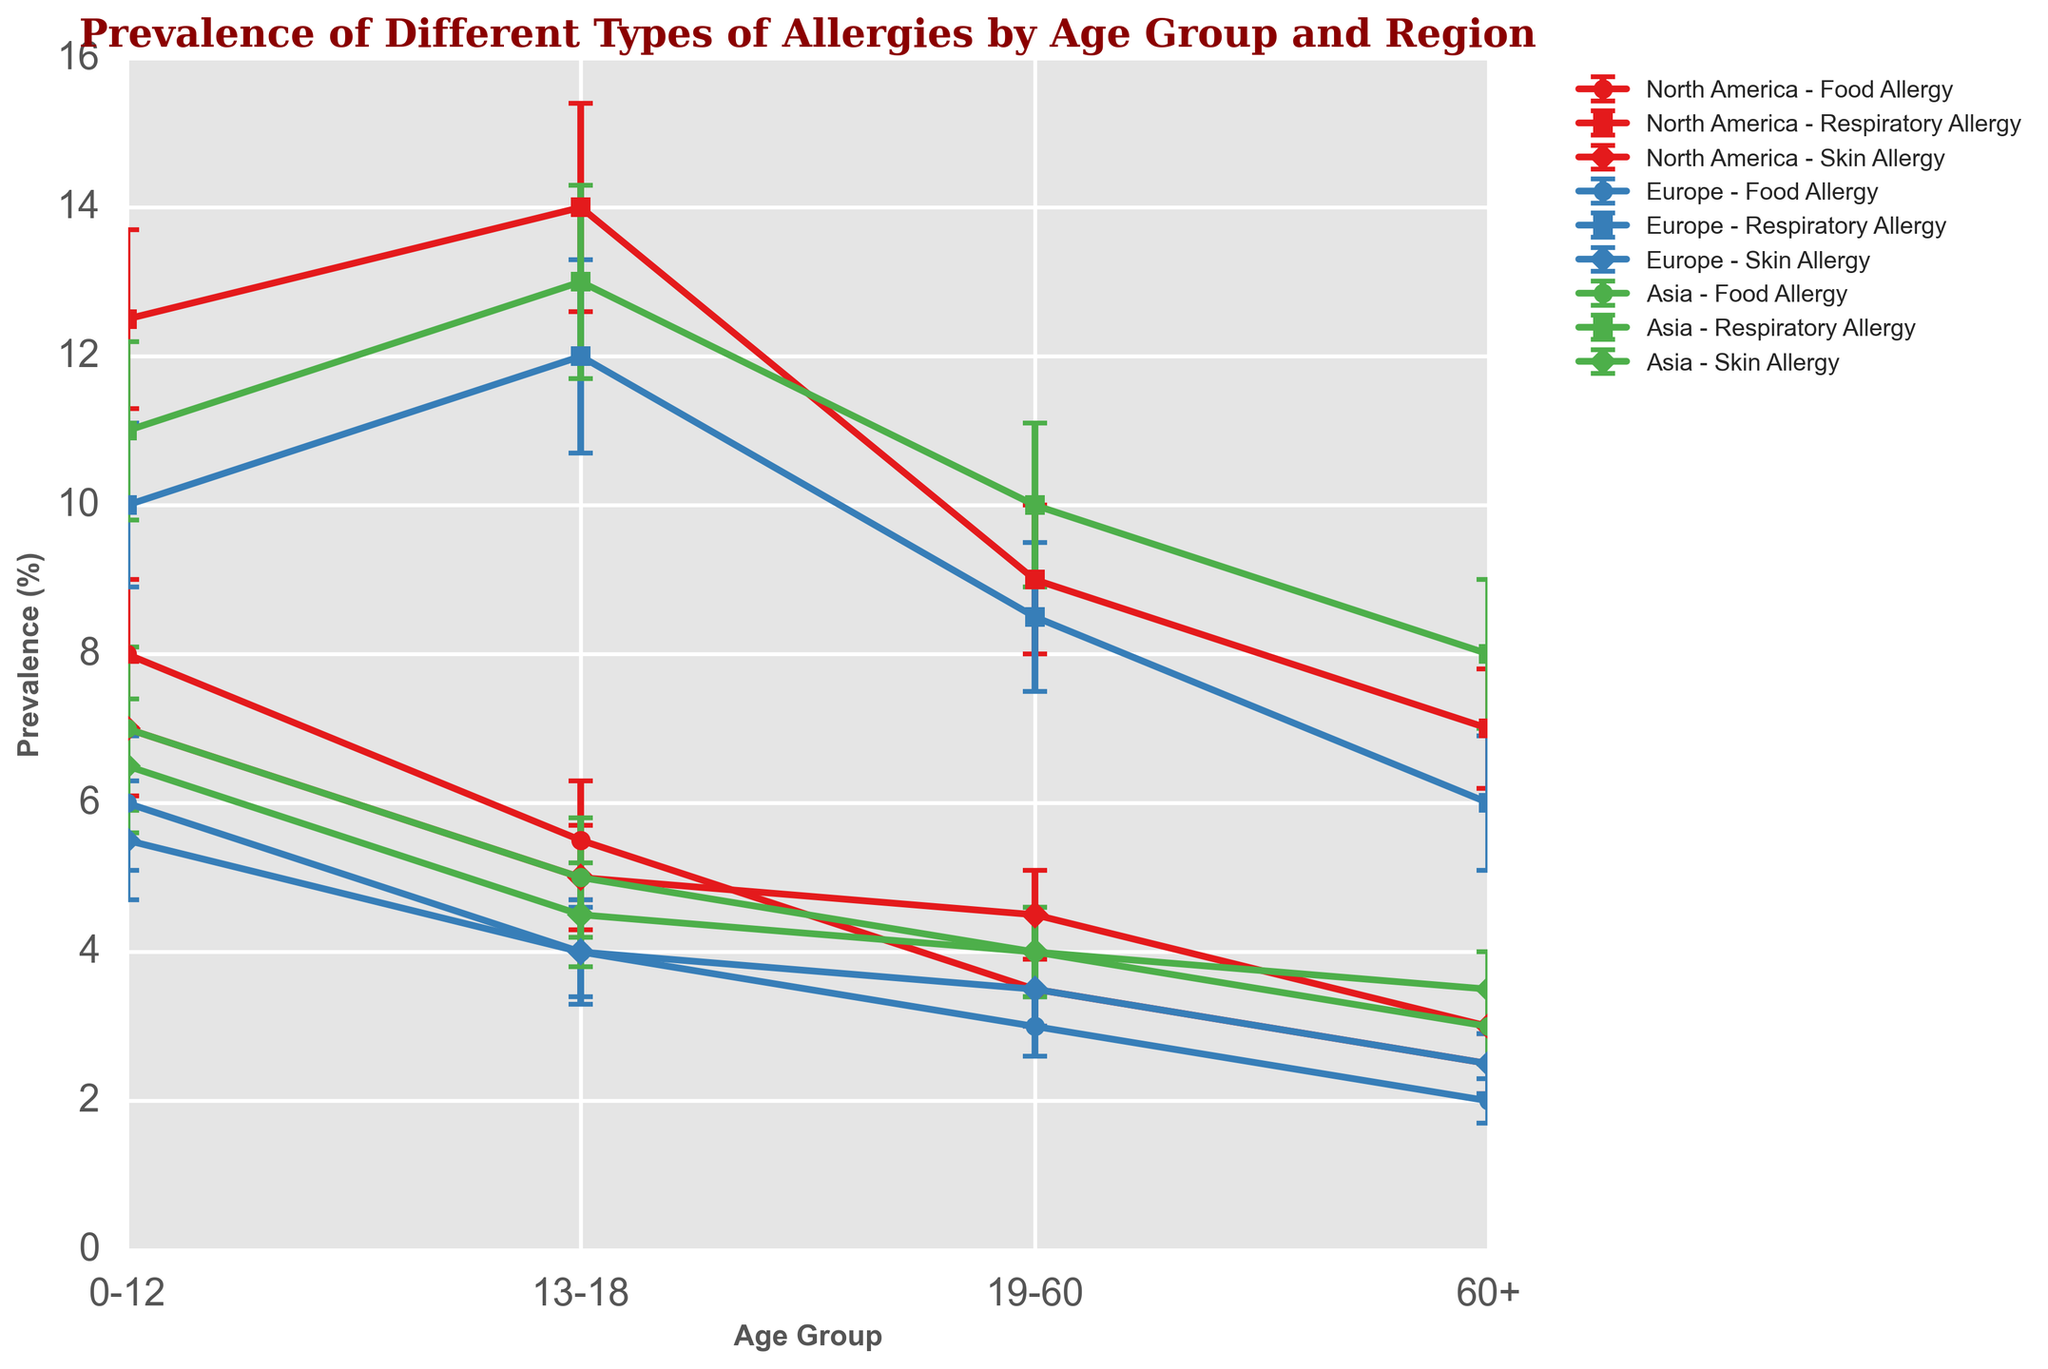Which allergy type shows the highest prevalence for the age group 0-12 in North America? To find out, look at the prevalence values for North America for the age group 0-12. The prevalence values for Food Allergy, Respiratory Allergy, and Skin Allergy are 8.0%, 12.5%, and 7.0%, respectively. The highest value among these is 12.5%, which is for Respiratory Allergy.
Answer: Respiratory Allergy Between Europe and Asia, which region has a higher prevalence of Respiratory Allergy in the 19-60 age group? Compare the prevalence values of Respiratory Allergy in the 19-60 age group for both Europe and Asia. Europe shows a prevalence of 8.5%, while Asia shows 10.0%. Therefore, Asia has a higher prevalence.
Answer: Asia What is the difference in prevalence of Food Allergy between the 0-12 and 60+ age groups in Europe? Look at the prevalence values of Food Allergy in the 0-12 and 60+ age groups in Europe. The values are 6.0% for 0-12 and 2.0% for 60+. The difference is 6.0% - 2.0% = 4.0%.
Answer: 4.0% Which region has the lowest standard deviation for Skin Allergy in the 13-18 age group? Compare standard deviations for Skin Allergy in the 13-18 age group across all regions. North America has 0.7%, Europe has 0.6%, and Asia has 0.7%. The lowest is 0.6%, which is in Europe.
Answer: Europe In which region and age group is the prevalence of Respiratory Allergy the lowest, and what is the value? Check the prevalence values of Respiratory Allergy across all regions and age groups. The lowest value is 6.0% in Europe for the 60+ age group.
Answer: Europe, 60+, 6.0% What is the average prevalence of Skin Allergy across all age groups in Asia? Calculate the average of Skin Allergy prevalence values in Asia: (6.5% for 0-12 + 4.5% for 13-18 + 4.0% for 19-60 + 3.5% for 60+) / 4 = 18.5% / 4 = 4.625%.
Answer: 4.625% Which allergy type in North America shows an increase in prevalence with age? Observing the prevalence trends for different allergy types in North America across age groups, Respiratory Allergy shows an initial increase to a peak in the 13-18 age group (14.0%) and then decreases. None show a consistent increase across all ages.
Answer: None Compare the prevalence of Food Allergy in the 0-12 age group across all regions. Which region has the highest prevalence? Check the Food Allergy prevalence for the 0-12 age group in North America (8.0%), Europe (6.0%), and Asia (7.0%). The highest is 8.0% in North America.
Answer: North America What is the combined average prevalence of Respiratory Allergy in the 13-18 and 19-60 age groups for North America? Calculate the average for Respiratory Allergy in North America for 13-18 and 19-60: (14.0% + 9.0%) / 2 = 11.5%.
Answer: 11.5% What is the difference in the standard deviations of Respiratory Allergy between the age groups 19-60 and 60+ in Asia? Look at the standard deviations for Respiratory Allergy in Asia for age groups 19-60 and 60+. The values are 1.1% and 1.0%, respectively. The difference is 1.1% - 1.0% = 0.1%.
Answer: 0.1% 